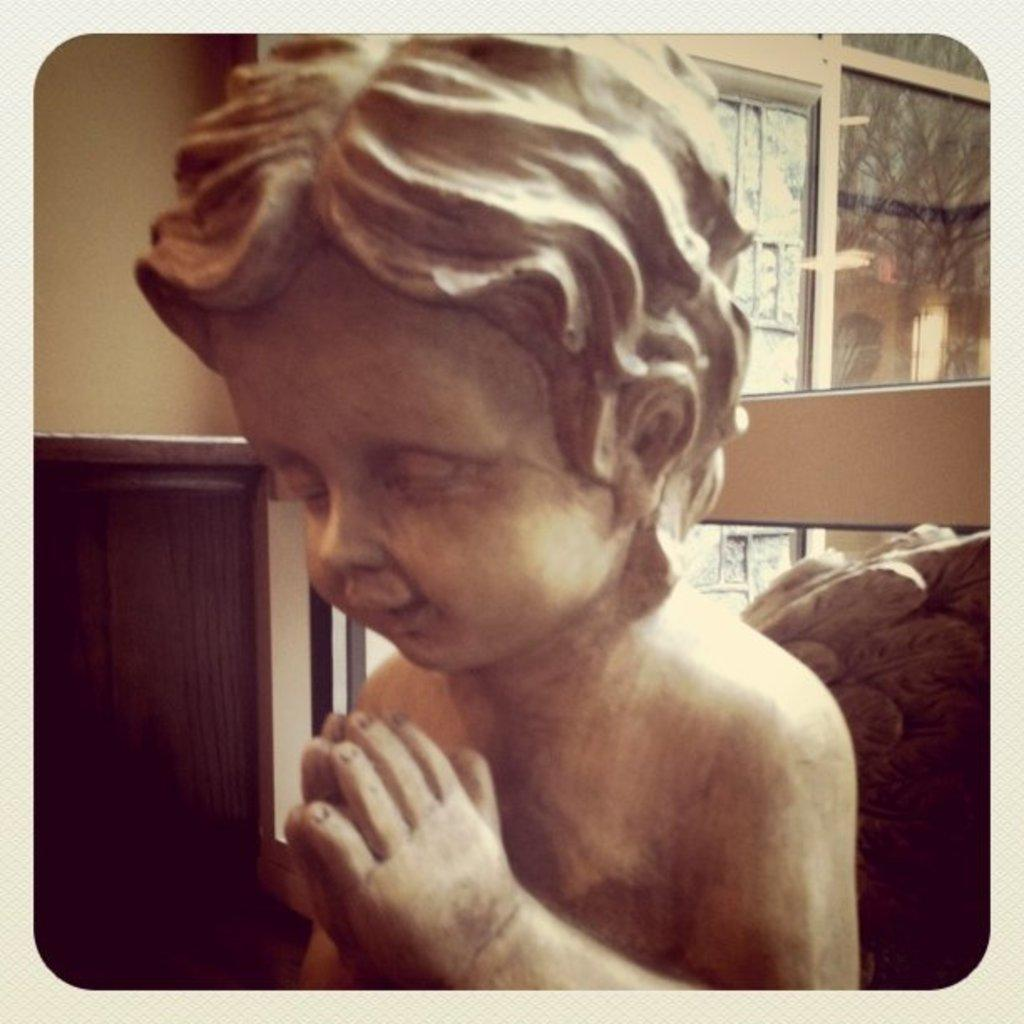What is the main subject in the center of the image? There is a baby statue in the center of the image. What can be seen in the background of the image? There is a building, a wall, glass, a window, and a fence in the background of the image. How many pigs are running around the baby statue in the image? There are no pigs present in the image, and they are not running around the baby statue. 